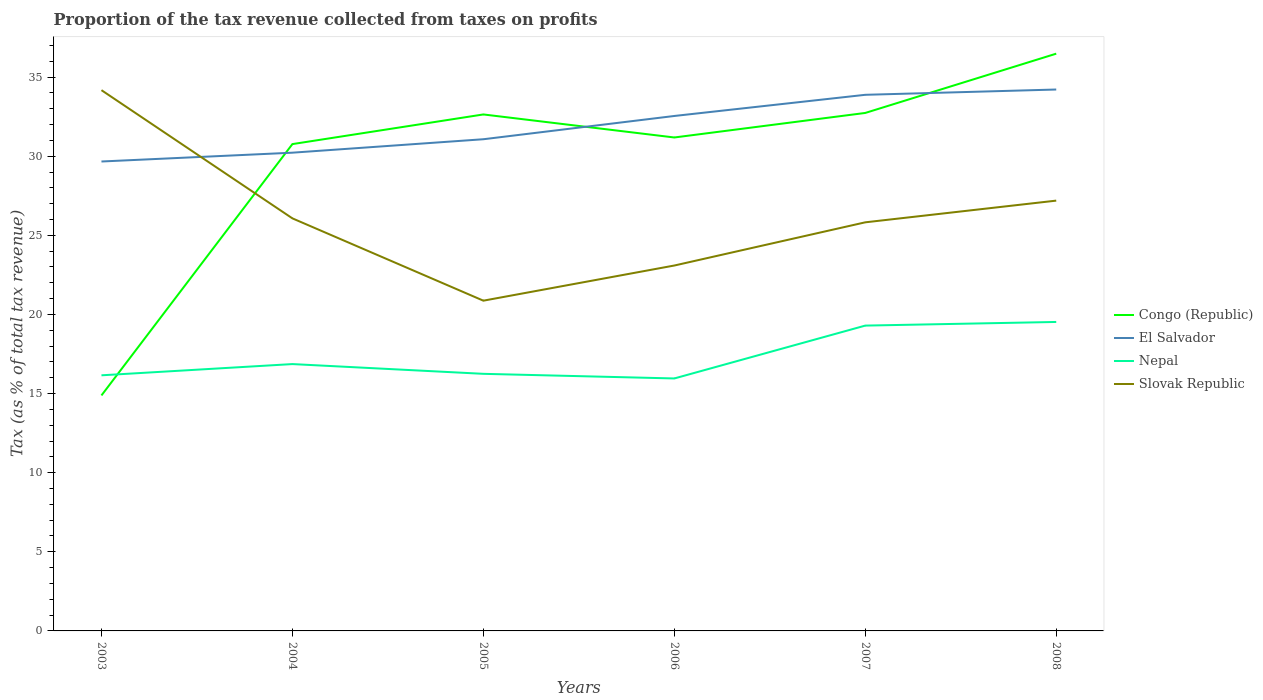How many different coloured lines are there?
Give a very brief answer. 4. Does the line corresponding to El Salvador intersect with the line corresponding to Slovak Republic?
Provide a short and direct response. Yes. Is the number of lines equal to the number of legend labels?
Your answer should be very brief. Yes. Across all years, what is the maximum proportion of the tax revenue collected in El Salvador?
Offer a very short reply. 29.66. In which year was the proportion of the tax revenue collected in Nepal maximum?
Your answer should be compact. 2006. What is the total proportion of the tax revenue collected in Congo (Republic) in the graph?
Keep it short and to the point. -16.3. What is the difference between the highest and the second highest proportion of the tax revenue collected in Slovak Republic?
Offer a very short reply. 13.3. How many lines are there?
Your response must be concise. 4. How many years are there in the graph?
Offer a terse response. 6. Does the graph contain any zero values?
Provide a short and direct response. No. Does the graph contain grids?
Offer a very short reply. No. What is the title of the graph?
Give a very brief answer. Proportion of the tax revenue collected from taxes on profits. What is the label or title of the Y-axis?
Provide a short and direct response. Tax (as % of total tax revenue). What is the Tax (as % of total tax revenue) in Congo (Republic) in 2003?
Make the answer very short. 14.88. What is the Tax (as % of total tax revenue) in El Salvador in 2003?
Your answer should be compact. 29.66. What is the Tax (as % of total tax revenue) of Nepal in 2003?
Your answer should be very brief. 16.15. What is the Tax (as % of total tax revenue) of Slovak Republic in 2003?
Keep it short and to the point. 34.17. What is the Tax (as % of total tax revenue) of Congo (Republic) in 2004?
Keep it short and to the point. 30.77. What is the Tax (as % of total tax revenue) in El Salvador in 2004?
Offer a terse response. 30.22. What is the Tax (as % of total tax revenue) of Nepal in 2004?
Give a very brief answer. 16.86. What is the Tax (as % of total tax revenue) in Slovak Republic in 2004?
Your response must be concise. 26.07. What is the Tax (as % of total tax revenue) in Congo (Republic) in 2005?
Offer a terse response. 32.64. What is the Tax (as % of total tax revenue) of El Salvador in 2005?
Provide a succinct answer. 31.07. What is the Tax (as % of total tax revenue) of Nepal in 2005?
Offer a very short reply. 16.25. What is the Tax (as % of total tax revenue) of Slovak Republic in 2005?
Your response must be concise. 20.87. What is the Tax (as % of total tax revenue) of Congo (Republic) in 2006?
Your answer should be compact. 31.18. What is the Tax (as % of total tax revenue) in El Salvador in 2006?
Ensure brevity in your answer.  32.54. What is the Tax (as % of total tax revenue) in Nepal in 2006?
Your answer should be very brief. 15.95. What is the Tax (as % of total tax revenue) in Slovak Republic in 2006?
Your answer should be very brief. 23.09. What is the Tax (as % of total tax revenue) of Congo (Republic) in 2007?
Offer a very short reply. 32.73. What is the Tax (as % of total tax revenue) in El Salvador in 2007?
Provide a succinct answer. 33.88. What is the Tax (as % of total tax revenue) in Nepal in 2007?
Your answer should be very brief. 19.3. What is the Tax (as % of total tax revenue) of Slovak Republic in 2007?
Provide a succinct answer. 25.82. What is the Tax (as % of total tax revenue) in Congo (Republic) in 2008?
Keep it short and to the point. 36.48. What is the Tax (as % of total tax revenue) in El Salvador in 2008?
Your answer should be compact. 34.21. What is the Tax (as % of total tax revenue) of Nepal in 2008?
Your response must be concise. 19.53. What is the Tax (as % of total tax revenue) of Slovak Republic in 2008?
Offer a very short reply. 27.19. Across all years, what is the maximum Tax (as % of total tax revenue) of Congo (Republic)?
Your answer should be compact. 36.48. Across all years, what is the maximum Tax (as % of total tax revenue) of El Salvador?
Make the answer very short. 34.21. Across all years, what is the maximum Tax (as % of total tax revenue) in Nepal?
Your answer should be compact. 19.53. Across all years, what is the maximum Tax (as % of total tax revenue) in Slovak Republic?
Your answer should be very brief. 34.17. Across all years, what is the minimum Tax (as % of total tax revenue) in Congo (Republic)?
Give a very brief answer. 14.88. Across all years, what is the minimum Tax (as % of total tax revenue) in El Salvador?
Your response must be concise. 29.66. Across all years, what is the minimum Tax (as % of total tax revenue) of Nepal?
Make the answer very short. 15.95. Across all years, what is the minimum Tax (as % of total tax revenue) in Slovak Republic?
Keep it short and to the point. 20.87. What is the total Tax (as % of total tax revenue) of Congo (Republic) in the graph?
Your answer should be compact. 178.68. What is the total Tax (as % of total tax revenue) of El Salvador in the graph?
Your answer should be very brief. 191.6. What is the total Tax (as % of total tax revenue) in Nepal in the graph?
Provide a succinct answer. 104.04. What is the total Tax (as % of total tax revenue) of Slovak Republic in the graph?
Your answer should be very brief. 157.22. What is the difference between the Tax (as % of total tax revenue) in Congo (Republic) in 2003 and that in 2004?
Provide a short and direct response. -15.88. What is the difference between the Tax (as % of total tax revenue) of El Salvador in 2003 and that in 2004?
Keep it short and to the point. -0.56. What is the difference between the Tax (as % of total tax revenue) in Nepal in 2003 and that in 2004?
Make the answer very short. -0.71. What is the difference between the Tax (as % of total tax revenue) in Slovak Republic in 2003 and that in 2004?
Offer a terse response. 8.1. What is the difference between the Tax (as % of total tax revenue) of Congo (Republic) in 2003 and that in 2005?
Keep it short and to the point. -17.76. What is the difference between the Tax (as % of total tax revenue) of El Salvador in 2003 and that in 2005?
Your response must be concise. -1.41. What is the difference between the Tax (as % of total tax revenue) of Nepal in 2003 and that in 2005?
Your answer should be compact. -0.09. What is the difference between the Tax (as % of total tax revenue) in Slovak Republic in 2003 and that in 2005?
Provide a succinct answer. 13.3. What is the difference between the Tax (as % of total tax revenue) in Congo (Republic) in 2003 and that in 2006?
Offer a very short reply. -16.3. What is the difference between the Tax (as % of total tax revenue) in El Salvador in 2003 and that in 2006?
Provide a succinct answer. -2.88. What is the difference between the Tax (as % of total tax revenue) of Nepal in 2003 and that in 2006?
Your answer should be compact. 0.2. What is the difference between the Tax (as % of total tax revenue) in Slovak Republic in 2003 and that in 2006?
Provide a short and direct response. 11.08. What is the difference between the Tax (as % of total tax revenue) in Congo (Republic) in 2003 and that in 2007?
Give a very brief answer. -17.85. What is the difference between the Tax (as % of total tax revenue) of El Salvador in 2003 and that in 2007?
Offer a terse response. -4.22. What is the difference between the Tax (as % of total tax revenue) of Nepal in 2003 and that in 2007?
Make the answer very short. -3.14. What is the difference between the Tax (as % of total tax revenue) of Slovak Republic in 2003 and that in 2007?
Your response must be concise. 8.35. What is the difference between the Tax (as % of total tax revenue) of Congo (Republic) in 2003 and that in 2008?
Give a very brief answer. -21.6. What is the difference between the Tax (as % of total tax revenue) in El Salvador in 2003 and that in 2008?
Ensure brevity in your answer.  -4.55. What is the difference between the Tax (as % of total tax revenue) of Nepal in 2003 and that in 2008?
Give a very brief answer. -3.37. What is the difference between the Tax (as % of total tax revenue) of Slovak Republic in 2003 and that in 2008?
Your response must be concise. 6.98. What is the difference between the Tax (as % of total tax revenue) in Congo (Republic) in 2004 and that in 2005?
Keep it short and to the point. -1.87. What is the difference between the Tax (as % of total tax revenue) in El Salvador in 2004 and that in 2005?
Your answer should be compact. -0.85. What is the difference between the Tax (as % of total tax revenue) of Nepal in 2004 and that in 2005?
Offer a very short reply. 0.62. What is the difference between the Tax (as % of total tax revenue) of Slovak Republic in 2004 and that in 2005?
Your answer should be compact. 5.2. What is the difference between the Tax (as % of total tax revenue) of Congo (Republic) in 2004 and that in 2006?
Ensure brevity in your answer.  -0.42. What is the difference between the Tax (as % of total tax revenue) of El Salvador in 2004 and that in 2006?
Your answer should be very brief. -2.32. What is the difference between the Tax (as % of total tax revenue) in Nepal in 2004 and that in 2006?
Your answer should be compact. 0.91. What is the difference between the Tax (as % of total tax revenue) in Slovak Republic in 2004 and that in 2006?
Your response must be concise. 2.98. What is the difference between the Tax (as % of total tax revenue) in Congo (Republic) in 2004 and that in 2007?
Your answer should be compact. -1.97. What is the difference between the Tax (as % of total tax revenue) of El Salvador in 2004 and that in 2007?
Provide a succinct answer. -3.66. What is the difference between the Tax (as % of total tax revenue) in Nepal in 2004 and that in 2007?
Your answer should be compact. -2.43. What is the difference between the Tax (as % of total tax revenue) of Slovak Republic in 2004 and that in 2007?
Keep it short and to the point. 0.25. What is the difference between the Tax (as % of total tax revenue) in Congo (Republic) in 2004 and that in 2008?
Your answer should be very brief. -5.71. What is the difference between the Tax (as % of total tax revenue) in El Salvador in 2004 and that in 2008?
Your answer should be very brief. -3.99. What is the difference between the Tax (as % of total tax revenue) of Nepal in 2004 and that in 2008?
Offer a very short reply. -2.66. What is the difference between the Tax (as % of total tax revenue) of Slovak Republic in 2004 and that in 2008?
Your answer should be compact. -1.12. What is the difference between the Tax (as % of total tax revenue) in Congo (Republic) in 2005 and that in 2006?
Your answer should be very brief. 1.46. What is the difference between the Tax (as % of total tax revenue) in El Salvador in 2005 and that in 2006?
Keep it short and to the point. -1.47. What is the difference between the Tax (as % of total tax revenue) of Nepal in 2005 and that in 2006?
Make the answer very short. 0.29. What is the difference between the Tax (as % of total tax revenue) in Slovak Republic in 2005 and that in 2006?
Give a very brief answer. -2.22. What is the difference between the Tax (as % of total tax revenue) of Congo (Republic) in 2005 and that in 2007?
Offer a terse response. -0.09. What is the difference between the Tax (as % of total tax revenue) of El Salvador in 2005 and that in 2007?
Your response must be concise. -2.81. What is the difference between the Tax (as % of total tax revenue) in Nepal in 2005 and that in 2007?
Your response must be concise. -3.05. What is the difference between the Tax (as % of total tax revenue) in Slovak Republic in 2005 and that in 2007?
Give a very brief answer. -4.95. What is the difference between the Tax (as % of total tax revenue) of Congo (Republic) in 2005 and that in 2008?
Offer a very short reply. -3.84. What is the difference between the Tax (as % of total tax revenue) of El Salvador in 2005 and that in 2008?
Your response must be concise. -3.14. What is the difference between the Tax (as % of total tax revenue) in Nepal in 2005 and that in 2008?
Keep it short and to the point. -3.28. What is the difference between the Tax (as % of total tax revenue) in Slovak Republic in 2005 and that in 2008?
Your response must be concise. -6.32. What is the difference between the Tax (as % of total tax revenue) in Congo (Republic) in 2006 and that in 2007?
Provide a short and direct response. -1.55. What is the difference between the Tax (as % of total tax revenue) of El Salvador in 2006 and that in 2007?
Give a very brief answer. -1.34. What is the difference between the Tax (as % of total tax revenue) of Nepal in 2006 and that in 2007?
Make the answer very short. -3.34. What is the difference between the Tax (as % of total tax revenue) of Slovak Republic in 2006 and that in 2007?
Keep it short and to the point. -2.73. What is the difference between the Tax (as % of total tax revenue) in Congo (Republic) in 2006 and that in 2008?
Offer a very short reply. -5.3. What is the difference between the Tax (as % of total tax revenue) of El Salvador in 2006 and that in 2008?
Give a very brief answer. -1.67. What is the difference between the Tax (as % of total tax revenue) of Nepal in 2006 and that in 2008?
Make the answer very short. -3.57. What is the difference between the Tax (as % of total tax revenue) of Slovak Republic in 2006 and that in 2008?
Provide a short and direct response. -4.1. What is the difference between the Tax (as % of total tax revenue) in Congo (Republic) in 2007 and that in 2008?
Your answer should be compact. -3.75. What is the difference between the Tax (as % of total tax revenue) in El Salvador in 2007 and that in 2008?
Give a very brief answer. -0.33. What is the difference between the Tax (as % of total tax revenue) in Nepal in 2007 and that in 2008?
Keep it short and to the point. -0.23. What is the difference between the Tax (as % of total tax revenue) in Slovak Republic in 2007 and that in 2008?
Your answer should be very brief. -1.37. What is the difference between the Tax (as % of total tax revenue) in Congo (Republic) in 2003 and the Tax (as % of total tax revenue) in El Salvador in 2004?
Your response must be concise. -15.34. What is the difference between the Tax (as % of total tax revenue) of Congo (Republic) in 2003 and the Tax (as % of total tax revenue) of Nepal in 2004?
Provide a short and direct response. -1.98. What is the difference between the Tax (as % of total tax revenue) of Congo (Republic) in 2003 and the Tax (as % of total tax revenue) of Slovak Republic in 2004?
Provide a succinct answer. -11.19. What is the difference between the Tax (as % of total tax revenue) in El Salvador in 2003 and the Tax (as % of total tax revenue) in Nepal in 2004?
Provide a succinct answer. 12.8. What is the difference between the Tax (as % of total tax revenue) of El Salvador in 2003 and the Tax (as % of total tax revenue) of Slovak Republic in 2004?
Offer a very short reply. 3.59. What is the difference between the Tax (as % of total tax revenue) of Nepal in 2003 and the Tax (as % of total tax revenue) of Slovak Republic in 2004?
Your answer should be compact. -9.92. What is the difference between the Tax (as % of total tax revenue) of Congo (Republic) in 2003 and the Tax (as % of total tax revenue) of El Salvador in 2005?
Provide a short and direct response. -16.19. What is the difference between the Tax (as % of total tax revenue) in Congo (Republic) in 2003 and the Tax (as % of total tax revenue) in Nepal in 2005?
Make the answer very short. -1.37. What is the difference between the Tax (as % of total tax revenue) in Congo (Republic) in 2003 and the Tax (as % of total tax revenue) in Slovak Republic in 2005?
Your answer should be very brief. -5.99. What is the difference between the Tax (as % of total tax revenue) in El Salvador in 2003 and the Tax (as % of total tax revenue) in Nepal in 2005?
Give a very brief answer. 13.42. What is the difference between the Tax (as % of total tax revenue) of El Salvador in 2003 and the Tax (as % of total tax revenue) of Slovak Republic in 2005?
Your response must be concise. 8.79. What is the difference between the Tax (as % of total tax revenue) in Nepal in 2003 and the Tax (as % of total tax revenue) in Slovak Republic in 2005?
Your answer should be compact. -4.72. What is the difference between the Tax (as % of total tax revenue) of Congo (Republic) in 2003 and the Tax (as % of total tax revenue) of El Salvador in 2006?
Your answer should be very brief. -17.66. What is the difference between the Tax (as % of total tax revenue) in Congo (Republic) in 2003 and the Tax (as % of total tax revenue) in Nepal in 2006?
Give a very brief answer. -1.07. What is the difference between the Tax (as % of total tax revenue) in Congo (Republic) in 2003 and the Tax (as % of total tax revenue) in Slovak Republic in 2006?
Make the answer very short. -8.21. What is the difference between the Tax (as % of total tax revenue) of El Salvador in 2003 and the Tax (as % of total tax revenue) of Nepal in 2006?
Ensure brevity in your answer.  13.71. What is the difference between the Tax (as % of total tax revenue) in El Salvador in 2003 and the Tax (as % of total tax revenue) in Slovak Republic in 2006?
Keep it short and to the point. 6.57. What is the difference between the Tax (as % of total tax revenue) in Nepal in 2003 and the Tax (as % of total tax revenue) in Slovak Republic in 2006?
Your response must be concise. -6.94. What is the difference between the Tax (as % of total tax revenue) of Congo (Republic) in 2003 and the Tax (as % of total tax revenue) of El Salvador in 2007?
Ensure brevity in your answer.  -19. What is the difference between the Tax (as % of total tax revenue) of Congo (Republic) in 2003 and the Tax (as % of total tax revenue) of Nepal in 2007?
Give a very brief answer. -4.41. What is the difference between the Tax (as % of total tax revenue) in Congo (Republic) in 2003 and the Tax (as % of total tax revenue) in Slovak Republic in 2007?
Offer a terse response. -10.94. What is the difference between the Tax (as % of total tax revenue) of El Salvador in 2003 and the Tax (as % of total tax revenue) of Nepal in 2007?
Your response must be concise. 10.37. What is the difference between the Tax (as % of total tax revenue) in El Salvador in 2003 and the Tax (as % of total tax revenue) in Slovak Republic in 2007?
Offer a terse response. 3.84. What is the difference between the Tax (as % of total tax revenue) in Nepal in 2003 and the Tax (as % of total tax revenue) in Slovak Republic in 2007?
Your response must be concise. -9.67. What is the difference between the Tax (as % of total tax revenue) in Congo (Republic) in 2003 and the Tax (as % of total tax revenue) in El Salvador in 2008?
Your answer should be compact. -19.33. What is the difference between the Tax (as % of total tax revenue) of Congo (Republic) in 2003 and the Tax (as % of total tax revenue) of Nepal in 2008?
Your response must be concise. -4.64. What is the difference between the Tax (as % of total tax revenue) in Congo (Republic) in 2003 and the Tax (as % of total tax revenue) in Slovak Republic in 2008?
Ensure brevity in your answer.  -12.31. What is the difference between the Tax (as % of total tax revenue) of El Salvador in 2003 and the Tax (as % of total tax revenue) of Nepal in 2008?
Your response must be concise. 10.14. What is the difference between the Tax (as % of total tax revenue) of El Salvador in 2003 and the Tax (as % of total tax revenue) of Slovak Republic in 2008?
Offer a terse response. 2.47. What is the difference between the Tax (as % of total tax revenue) of Nepal in 2003 and the Tax (as % of total tax revenue) of Slovak Republic in 2008?
Your answer should be compact. -11.04. What is the difference between the Tax (as % of total tax revenue) in Congo (Republic) in 2004 and the Tax (as % of total tax revenue) in El Salvador in 2005?
Provide a succinct answer. -0.31. What is the difference between the Tax (as % of total tax revenue) of Congo (Republic) in 2004 and the Tax (as % of total tax revenue) of Nepal in 2005?
Give a very brief answer. 14.52. What is the difference between the Tax (as % of total tax revenue) of Congo (Republic) in 2004 and the Tax (as % of total tax revenue) of Slovak Republic in 2005?
Your answer should be very brief. 9.9. What is the difference between the Tax (as % of total tax revenue) of El Salvador in 2004 and the Tax (as % of total tax revenue) of Nepal in 2005?
Provide a short and direct response. 13.98. What is the difference between the Tax (as % of total tax revenue) of El Salvador in 2004 and the Tax (as % of total tax revenue) of Slovak Republic in 2005?
Offer a terse response. 9.35. What is the difference between the Tax (as % of total tax revenue) in Nepal in 2004 and the Tax (as % of total tax revenue) in Slovak Republic in 2005?
Make the answer very short. -4.01. What is the difference between the Tax (as % of total tax revenue) of Congo (Republic) in 2004 and the Tax (as % of total tax revenue) of El Salvador in 2006?
Provide a short and direct response. -1.78. What is the difference between the Tax (as % of total tax revenue) in Congo (Republic) in 2004 and the Tax (as % of total tax revenue) in Nepal in 2006?
Provide a short and direct response. 14.81. What is the difference between the Tax (as % of total tax revenue) in Congo (Republic) in 2004 and the Tax (as % of total tax revenue) in Slovak Republic in 2006?
Keep it short and to the point. 7.67. What is the difference between the Tax (as % of total tax revenue) in El Salvador in 2004 and the Tax (as % of total tax revenue) in Nepal in 2006?
Make the answer very short. 14.27. What is the difference between the Tax (as % of total tax revenue) of El Salvador in 2004 and the Tax (as % of total tax revenue) of Slovak Republic in 2006?
Ensure brevity in your answer.  7.13. What is the difference between the Tax (as % of total tax revenue) of Nepal in 2004 and the Tax (as % of total tax revenue) of Slovak Republic in 2006?
Give a very brief answer. -6.23. What is the difference between the Tax (as % of total tax revenue) of Congo (Republic) in 2004 and the Tax (as % of total tax revenue) of El Salvador in 2007?
Your answer should be very brief. -3.11. What is the difference between the Tax (as % of total tax revenue) of Congo (Republic) in 2004 and the Tax (as % of total tax revenue) of Nepal in 2007?
Offer a very short reply. 11.47. What is the difference between the Tax (as % of total tax revenue) in Congo (Republic) in 2004 and the Tax (as % of total tax revenue) in Slovak Republic in 2007?
Ensure brevity in your answer.  4.94. What is the difference between the Tax (as % of total tax revenue) in El Salvador in 2004 and the Tax (as % of total tax revenue) in Nepal in 2007?
Ensure brevity in your answer.  10.93. What is the difference between the Tax (as % of total tax revenue) in El Salvador in 2004 and the Tax (as % of total tax revenue) in Slovak Republic in 2007?
Offer a terse response. 4.4. What is the difference between the Tax (as % of total tax revenue) of Nepal in 2004 and the Tax (as % of total tax revenue) of Slovak Republic in 2007?
Offer a very short reply. -8.96. What is the difference between the Tax (as % of total tax revenue) in Congo (Republic) in 2004 and the Tax (as % of total tax revenue) in El Salvador in 2008?
Your answer should be very brief. -3.45. What is the difference between the Tax (as % of total tax revenue) in Congo (Republic) in 2004 and the Tax (as % of total tax revenue) in Nepal in 2008?
Offer a terse response. 11.24. What is the difference between the Tax (as % of total tax revenue) of Congo (Republic) in 2004 and the Tax (as % of total tax revenue) of Slovak Republic in 2008?
Provide a succinct answer. 3.57. What is the difference between the Tax (as % of total tax revenue) in El Salvador in 2004 and the Tax (as % of total tax revenue) in Nepal in 2008?
Provide a succinct answer. 10.7. What is the difference between the Tax (as % of total tax revenue) in El Salvador in 2004 and the Tax (as % of total tax revenue) in Slovak Republic in 2008?
Offer a terse response. 3.03. What is the difference between the Tax (as % of total tax revenue) of Nepal in 2004 and the Tax (as % of total tax revenue) of Slovak Republic in 2008?
Provide a succinct answer. -10.33. What is the difference between the Tax (as % of total tax revenue) in Congo (Republic) in 2005 and the Tax (as % of total tax revenue) in El Salvador in 2006?
Offer a terse response. 0.1. What is the difference between the Tax (as % of total tax revenue) of Congo (Republic) in 2005 and the Tax (as % of total tax revenue) of Nepal in 2006?
Provide a short and direct response. 16.68. What is the difference between the Tax (as % of total tax revenue) of Congo (Republic) in 2005 and the Tax (as % of total tax revenue) of Slovak Republic in 2006?
Make the answer very short. 9.55. What is the difference between the Tax (as % of total tax revenue) in El Salvador in 2005 and the Tax (as % of total tax revenue) in Nepal in 2006?
Ensure brevity in your answer.  15.12. What is the difference between the Tax (as % of total tax revenue) of El Salvador in 2005 and the Tax (as % of total tax revenue) of Slovak Republic in 2006?
Ensure brevity in your answer.  7.98. What is the difference between the Tax (as % of total tax revenue) in Nepal in 2005 and the Tax (as % of total tax revenue) in Slovak Republic in 2006?
Your answer should be very brief. -6.84. What is the difference between the Tax (as % of total tax revenue) of Congo (Republic) in 2005 and the Tax (as % of total tax revenue) of El Salvador in 2007?
Ensure brevity in your answer.  -1.24. What is the difference between the Tax (as % of total tax revenue) in Congo (Republic) in 2005 and the Tax (as % of total tax revenue) in Nepal in 2007?
Offer a terse response. 13.34. What is the difference between the Tax (as % of total tax revenue) in Congo (Republic) in 2005 and the Tax (as % of total tax revenue) in Slovak Republic in 2007?
Provide a succinct answer. 6.82. What is the difference between the Tax (as % of total tax revenue) in El Salvador in 2005 and the Tax (as % of total tax revenue) in Nepal in 2007?
Keep it short and to the point. 11.78. What is the difference between the Tax (as % of total tax revenue) in El Salvador in 2005 and the Tax (as % of total tax revenue) in Slovak Republic in 2007?
Make the answer very short. 5.25. What is the difference between the Tax (as % of total tax revenue) in Nepal in 2005 and the Tax (as % of total tax revenue) in Slovak Republic in 2007?
Offer a terse response. -9.57. What is the difference between the Tax (as % of total tax revenue) of Congo (Republic) in 2005 and the Tax (as % of total tax revenue) of El Salvador in 2008?
Keep it short and to the point. -1.58. What is the difference between the Tax (as % of total tax revenue) in Congo (Republic) in 2005 and the Tax (as % of total tax revenue) in Nepal in 2008?
Provide a succinct answer. 13.11. What is the difference between the Tax (as % of total tax revenue) of Congo (Republic) in 2005 and the Tax (as % of total tax revenue) of Slovak Republic in 2008?
Give a very brief answer. 5.45. What is the difference between the Tax (as % of total tax revenue) in El Salvador in 2005 and the Tax (as % of total tax revenue) in Nepal in 2008?
Provide a short and direct response. 11.55. What is the difference between the Tax (as % of total tax revenue) in El Salvador in 2005 and the Tax (as % of total tax revenue) in Slovak Republic in 2008?
Your answer should be compact. 3.88. What is the difference between the Tax (as % of total tax revenue) in Nepal in 2005 and the Tax (as % of total tax revenue) in Slovak Republic in 2008?
Provide a short and direct response. -10.95. What is the difference between the Tax (as % of total tax revenue) of Congo (Republic) in 2006 and the Tax (as % of total tax revenue) of El Salvador in 2007?
Your answer should be very brief. -2.7. What is the difference between the Tax (as % of total tax revenue) of Congo (Republic) in 2006 and the Tax (as % of total tax revenue) of Nepal in 2007?
Offer a very short reply. 11.89. What is the difference between the Tax (as % of total tax revenue) of Congo (Republic) in 2006 and the Tax (as % of total tax revenue) of Slovak Republic in 2007?
Offer a terse response. 5.36. What is the difference between the Tax (as % of total tax revenue) of El Salvador in 2006 and the Tax (as % of total tax revenue) of Nepal in 2007?
Offer a terse response. 13.25. What is the difference between the Tax (as % of total tax revenue) of El Salvador in 2006 and the Tax (as % of total tax revenue) of Slovak Republic in 2007?
Provide a succinct answer. 6.72. What is the difference between the Tax (as % of total tax revenue) in Nepal in 2006 and the Tax (as % of total tax revenue) in Slovak Republic in 2007?
Give a very brief answer. -9.87. What is the difference between the Tax (as % of total tax revenue) of Congo (Republic) in 2006 and the Tax (as % of total tax revenue) of El Salvador in 2008?
Offer a terse response. -3.03. What is the difference between the Tax (as % of total tax revenue) in Congo (Republic) in 2006 and the Tax (as % of total tax revenue) in Nepal in 2008?
Give a very brief answer. 11.66. What is the difference between the Tax (as % of total tax revenue) in Congo (Republic) in 2006 and the Tax (as % of total tax revenue) in Slovak Republic in 2008?
Offer a terse response. 3.99. What is the difference between the Tax (as % of total tax revenue) in El Salvador in 2006 and the Tax (as % of total tax revenue) in Nepal in 2008?
Provide a short and direct response. 13.02. What is the difference between the Tax (as % of total tax revenue) in El Salvador in 2006 and the Tax (as % of total tax revenue) in Slovak Republic in 2008?
Provide a succinct answer. 5.35. What is the difference between the Tax (as % of total tax revenue) in Nepal in 2006 and the Tax (as % of total tax revenue) in Slovak Republic in 2008?
Provide a succinct answer. -11.24. What is the difference between the Tax (as % of total tax revenue) in Congo (Republic) in 2007 and the Tax (as % of total tax revenue) in El Salvador in 2008?
Provide a short and direct response. -1.48. What is the difference between the Tax (as % of total tax revenue) in Congo (Republic) in 2007 and the Tax (as % of total tax revenue) in Nepal in 2008?
Provide a short and direct response. 13.21. What is the difference between the Tax (as % of total tax revenue) of Congo (Republic) in 2007 and the Tax (as % of total tax revenue) of Slovak Republic in 2008?
Offer a very short reply. 5.54. What is the difference between the Tax (as % of total tax revenue) of El Salvador in 2007 and the Tax (as % of total tax revenue) of Nepal in 2008?
Your answer should be very brief. 14.35. What is the difference between the Tax (as % of total tax revenue) of El Salvador in 2007 and the Tax (as % of total tax revenue) of Slovak Republic in 2008?
Give a very brief answer. 6.69. What is the difference between the Tax (as % of total tax revenue) of Nepal in 2007 and the Tax (as % of total tax revenue) of Slovak Republic in 2008?
Give a very brief answer. -7.9. What is the average Tax (as % of total tax revenue) in Congo (Republic) per year?
Keep it short and to the point. 29.78. What is the average Tax (as % of total tax revenue) of El Salvador per year?
Ensure brevity in your answer.  31.93. What is the average Tax (as % of total tax revenue) in Nepal per year?
Your answer should be compact. 17.34. What is the average Tax (as % of total tax revenue) of Slovak Republic per year?
Keep it short and to the point. 26.2. In the year 2003, what is the difference between the Tax (as % of total tax revenue) in Congo (Republic) and Tax (as % of total tax revenue) in El Salvador?
Keep it short and to the point. -14.78. In the year 2003, what is the difference between the Tax (as % of total tax revenue) in Congo (Republic) and Tax (as % of total tax revenue) in Nepal?
Keep it short and to the point. -1.27. In the year 2003, what is the difference between the Tax (as % of total tax revenue) in Congo (Republic) and Tax (as % of total tax revenue) in Slovak Republic?
Provide a short and direct response. -19.29. In the year 2003, what is the difference between the Tax (as % of total tax revenue) of El Salvador and Tax (as % of total tax revenue) of Nepal?
Make the answer very short. 13.51. In the year 2003, what is the difference between the Tax (as % of total tax revenue) of El Salvador and Tax (as % of total tax revenue) of Slovak Republic?
Keep it short and to the point. -4.51. In the year 2003, what is the difference between the Tax (as % of total tax revenue) of Nepal and Tax (as % of total tax revenue) of Slovak Republic?
Offer a very short reply. -18.02. In the year 2004, what is the difference between the Tax (as % of total tax revenue) in Congo (Republic) and Tax (as % of total tax revenue) in El Salvador?
Provide a short and direct response. 0.54. In the year 2004, what is the difference between the Tax (as % of total tax revenue) of Congo (Republic) and Tax (as % of total tax revenue) of Nepal?
Offer a very short reply. 13.9. In the year 2004, what is the difference between the Tax (as % of total tax revenue) in Congo (Republic) and Tax (as % of total tax revenue) in Slovak Republic?
Your answer should be compact. 4.69. In the year 2004, what is the difference between the Tax (as % of total tax revenue) of El Salvador and Tax (as % of total tax revenue) of Nepal?
Your response must be concise. 13.36. In the year 2004, what is the difference between the Tax (as % of total tax revenue) in El Salvador and Tax (as % of total tax revenue) in Slovak Republic?
Offer a very short reply. 4.15. In the year 2004, what is the difference between the Tax (as % of total tax revenue) in Nepal and Tax (as % of total tax revenue) in Slovak Republic?
Your answer should be compact. -9.21. In the year 2005, what is the difference between the Tax (as % of total tax revenue) of Congo (Republic) and Tax (as % of total tax revenue) of El Salvador?
Your answer should be compact. 1.57. In the year 2005, what is the difference between the Tax (as % of total tax revenue) in Congo (Republic) and Tax (as % of total tax revenue) in Nepal?
Your answer should be very brief. 16.39. In the year 2005, what is the difference between the Tax (as % of total tax revenue) in Congo (Republic) and Tax (as % of total tax revenue) in Slovak Republic?
Offer a very short reply. 11.77. In the year 2005, what is the difference between the Tax (as % of total tax revenue) of El Salvador and Tax (as % of total tax revenue) of Nepal?
Offer a terse response. 14.82. In the year 2005, what is the difference between the Tax (as % of total tax revenue) of El Salvador and Tax (as % of total tax revenue) of Slovak Republic?
Offer a very short reply. 10.2. In the year 2005, what is the difference between the Tax (as % of total tax revenue) in Nepal and Tax (as % of total tax revenue) in Slovak Republic?
Provide a short and direct response. -4.62. In the year 2006, what is the difference between the Tax (as % of total tax revenue) of Congo (Republic) and Tax (as % of total tax revenue) of El Salvador?
Give a very brief answer. -1.36. In the year 2006, what is the difference between the Tax (as % of total tax revenue) in Congo (Republic) and Tax (as % of total tax revenue) in Nepal?
Ensure brevity in your answer.  15.23. In the year 2006, what is the difference between the Tax (as % of total tax revenue) in Congo (Republic) and Tax (as % of total tax revenue) in Slovak Republic?
Keep it short and to the point. 8.09. In the year 2006, what is the difference between the Tax (as % of total tax revenue) in El Salvador and Tax (as % of total tax revenue) in Nepal?
Your answer should be compact. 16.59. In the year 2006, what is the difference between the Tax (as % of total tax revenue) of El Salvador and Tax (as % of total tax revenue) of Slovak Republic?
Offer a terse response. 9.45. In the year 2006, what is the difference between the Tax (as % of total tax revenue) in Nepal and Tax (as % of total tax revenue) in Slovak Republic?
Your answer should be compact. -7.14. In the year 2007, what is the difference between the Tax (as % of total tax revenue) in Congo (Republic) and Tax (as % of total tax revenue) in El Salvador?
Your response must be concise. -1.15. In the year 2007, what is the difference between the Tax (as % of total tax revenue) in Congo (Republic) and Tax (as % of total tax revenue) in Nepal?
Offer a terse response. 13.44. In the year 2007, what is the difference between the Tax (as % of total tax revenue) of Congo (Republic) and Tax (as % of total tax revenue) of Slovak Republic?
Offer a very short reply. 6.91. In the year 2007, what is the difference between the Tax (as % of total tax revenue) of El Salvador and Tax (as % of total tax revenue) of Nepal?
Your answer should be very brief. 14.58. In the year 2007, what is the difference between the Tax (as % of total tax revenue) of El Salvador and Tax (as % of total tax revenue) of Slovak Republic?
Provide a succinct answer. 8.06. In the year 2007, what is the difference between the Tax (as % of total tax revenue) of Nepal and Tax (as % of total tax revenue) of Slovak Republic?
Your answer should be very brief. -6.53. In the year 2008, what is the difference between the Tax (as % of total tax revenue) in Congo (Republic) and Tax (as % of total tax revenue) in El Salvador?
Make the answer very short. 2.27. In the year 2008, what is the difference between the Tax (as % of total tax revenue) in Congo (Republic) and Tax (as % of total tax revenue) in Nepal?
Provide a succinct answer. 16.95. In the year 2008, what is the difference between the Tax (as % of total tax revenue) of Congo (Republic) and Tax (as % of total tax revenue) of Slovak Republic?
Your answer should be compact. 9.29. In the year 2008, what is the difference between the Tax (as % of total tax revenue) of El Salvador and Tax (as % of total tax revenue) of Nepal?
Provide a succinct answer. 14.69. In the year 2008, what is the difference between the Tax (as % of total tax revenue) in El Salvador and Tax (as % of total tax revenue) in Slovak Republic?
Your answer should be compact. 7.02. In the year 2008, what is the difference between the Tax (as % of total tax revenue) of Nepal and Tax (as % of total tax revenue) of Slovak Republic?
Offer a terse response. -7.67. What is the ratio of the Tax (as % of total tax revenue) in Congo (Republic) in 2003 to that in 2004?
Offer a terse response. 0.48. What is the ratio of the Tax (as % of total tax revenue) of El Salvador in 2003 to that in 2004?
Provide a short and direct response. 0.98. What is the ratio of the Tax (as % of total tax revenue) in Nepal in 2003 to that in 2004?
Provide a succinct answer. 0.96. What is the ratio of the Tax (as % of total tax revenue) in Slovak Republic in 2003 to that in 2004?
Provide a short and direct response. 1.31. What is the ratio of the Tax (as % of total tax revenue) in Congo (Republic) in 2003 to that in 2005?
Provide a short and direct response. 0.46. What is the ratio of the Tax (as % of total tax revenue) of El Salvador in 2003 to that in 2005?
Your response must be concise. 0.95. What is the ratio of the Tax (as % of total tax revenue) in Nepal in 2003 to that in 2005?
Make the answer very short. 0.99. What is the ratio of the Tax (as % of total tax revenue) in Slovak Republic in 2003 to that in 2005?
Your answer should be very brief. 1.64. What is the ratio of the Tax (as % of total tax revenue) of Congo (Republic) in 2003 to that in 2006?
Give a very brief answer. 0.48. What is the ratio of the Tax (as % of total tax revenue) of El Salvador in 2003 to that in 2006?
Ensure brevity in your answer.  0.91. What is the ratio of the Tax (as % of total tax revenue) of Nepal in 2003 to that in 2006?
Make the answer very short. 1.01. What is the ratio of the Tax (as % of total tax revenue) of Slovak Republic in 2003 to that in 2006?
Give a very brief answer. 1.48. What is the ratio of the Tax (as % of total tax revenue) in Congo (Republic) in 2003 to that in 2007?
Give a very brief answer. 0.45. What is the ratio of the Tax (as % of total tax revenue) of El Salvador in 2003 to that in 2007?
Offer a terse response. 0.88. What is the ratio of the Tax (as % of total tax revenue) in Nepal in 2003 to that in 2007?
Provide a short and direct response. 0.84. What is the ratio of the Tax (as % of total tax revenue) of Slovak Republic in 2003 to that in 2007?
Your answer should be compact. 1.32. What is the ratio of the Tax (as % of total tax revenue) of Congo (Republic) in 2003 to that in 2008?
Ensure brevity in your answer.  0.41. What is the ratio of the Tax (as % of total tax revenue) in El Salvador in 2003 to that in 2008?
Give a very brief answer. 0.87. What is the ratio of the Tax (as % of total tax revenue) of Nepal in 2003 to that in 2008?
Your response must be concise. 0.83. What is the ratio of the Tax (as % of total tax revenue) of Slovak Republic in 2003 to that in 2008?
Your answer should be compact. 1.26. What is the ratio of the Tax (as % of total tax revenue) in Congo (Republic) in 2004 to that in 2005?
Keep it short and to the point. 0.94. What is the ratio of the Tax (as % of total tax revenue) of El Salvador in 2004 to that in 2005?
Give a very brief answer. 0.97. What is the ratio of the Tax (as % of total tax revenue) of Nepal in 2004 to that in 2005?
Your answer should be compact. 1.04. What is the ratio of the Tax (as % of total tax revenue) in Slovak Republic in 2004 to that in 2005?
Provide a short and direct response. 1.25. What is the ratio of the Tax (as % of total tax revenue) in Congo (Republic) in 2004 to that in 2006?
Offer a terse response. 0.99. What is the ratio of the Tax (as % of total tax revenue) in El Salvador in 2004 to that in 2006?
Give a very brief answer. 0.93. What is the ratio of the Tax (as % of total tax revenue) of Nepal in 2004 to that in 2006?
Give a very brief answer. 1.06. What is the ratio of the Tax (as % of total tax revenue) in Slovak Republic in 2004 to that in 2006?
Your response must be concise. 1.13. What is the ratio of the Tax (as % of total tax revenue) of Congo (Republic) in 2004 to that in 2007?
Ensure brevity in your answer.  0.94. What is the ratio of the Tax (as % of total tax revenue) in El Salvador in 2004 to that in 2007?
Make the answer very short. 0.89. What is the ratio of the Tax (as % of total tax revenue) in Nepal in 2004 to that in 2007?
Give a very brief answer. 0.87. What is the ratio of the Tax (as % of total tax revenue) in Slovak Republic in 2004 to that in 2007?
Keep it short and to the point. 1.01. What is the ratio of the Tax (as % of total tax revenue) in Congo (Republic) in 2004 to that in 2008?
Offer a very short reply. 0.84. What is the ratio of the Tax (as % of total tax revenue) in El Salvador in 2004 to that in 2008?
Provide a short and direct response. 0.88. What is the ratio of the Tax (as % of total tax revenue) in Nepal in 2004 to that in 2008?
Your answer should be compact. 0.86. What is the ratio of the Tax (as % of total tax revenue) of Slovak Republic in 2004 to that in 2008?
Provide a short and direct response. 0.96. What is the ratio of the Tax (as % of total tax revenue) of Congo (Republic) in 2005 to that in 2006?
Your answer should be very brief. 1.05. What is the ratio of the Tax (as % of total tax revenue) of El Salvador in 2005 to that in 2006?
Give a very brief answer. 0.95. What is the ratio of the Tax (as % of total tax revenue) of Nepal in 2005 to that in 2006?
Give a very brief answer. 1.02. What is the ratio of the Tax (as % of total tax revenue) in Slovak Republic in 2005 to that in 2006?
Your response must be concise. 0.9. What is the ratio of the Tax (as % of total tax revenue) in El Salvador in 2005 to that in 2007?
Your answer should be compact. 0.92. What is the ratio of the Tax (as % of total tax revenue) of Nepal in 2005 to that in 2007?
Give a very brief answer. 0.84. What is the ratio of the Tax (as % of total tax revenue) of Slovak Republic in 2005 to that in 2007?
Keep it short and to the point. 0.81. What is the ratio of the Tax (as % of total tax revenue) in Congo (Republic) in 2005 to that in 2008?
Provide a short and direct response. 0.89. What is the ratio of the Tax (as % of total tax revenue) in El Salvador in 2005 to that in 2008?
Offer a terse response. 0.91. What is the ratio of the Tax (as % of total tax revenue) of Nepal in 2005 to that in 2008?
Your response must be concise. 0.83. What is the ratio of the Tax (as % of total tax revenue) in Slovak Republic in 2005 to that in 2008?
Keep it short and to the point. 0.77. What is the ratio of the Tax (as % of total tax revenue) in Congo (Republic) in 2006 to that in 2007?
Your response must be concise. 0.95. What is the ratio of the Tax (as % of total tax revenue) in El Salvador in 2006 to that in 2007?
Your response must be concise. 0.96. What is the ratio of the Tax (as % of total tax revenue) in Nepal in 2006 to that in 2007?
Your answer should be compact. 0.83. What is the ratio of the Tax (as % of total tax revenue) of Slovak Republic in 2006 to that in 2007?
Your answer should be very brief. 0.89. What is the ratio of the Tax (as % of total tax revenue) of Congo (Republic) in 2006 to that in 2008?
Your answer should be very brief. 0.85. What is the ratio of the Tax (as % of total tax revenue) of El Salvador in 2006 to that in 2008?
Keep it short and to the point. 0.95. What is the ratio of the Tax (as % of total tax revenue) of Nepal in 2006 to that in 2008?
Keep it short and to the point. 0.82. What is the ratio of the Tax (as % of total tax revenue) in Slovak Republic in 2006 to that in 2008?
Offer a very short reply. 0.85. What is the ratio of the Tax (as % of total tax revenue) of Congo (Republic) in 2007 to that in 2008?
Your answer should be very brief. 0.9. What is the ratio of the Tax (as % of total tax revenue) of El Salvador in 2007 to that in 2008?
Provide a short and direct response. 0.99. What is the ratio of the Tax (as % of total tax revenue) of Slovak Republic in 2007 to that in 2008?
Offer a very short reply. 0.95. What is the difference between the highest and the second highest Tax (as % of total tax revenue) of Congo (Republic)?
Keep it short and to the point. 3.75. What is the difference between the highest and the second highest Tax (as % of total tax revenue) of El Salvador?
Your response must be concise. 0.33. What is the difference between the highest and the second highest Tax (as % of total tax revenue) in Nepal?
Your answer should be compact. 0.23. What is the difference between the highest and the second highest Tax (as % of total tax revenue) in Slovak Republic?
Give a very brief answer. 6.98. What is the difference between the highest and the lowest Tax (as % of total tax revenue) of Congo (Republic)?
Offer a terse response. 21.6. What is the difference between the highest and the lowest Tax (as % of total tax revenue) in El Salvador?
Make the answer very short. 4.55. What is the difference between the highest and the lowest Tax (as % of total tax revenue) in Nepal?
Provide a short and direct response. 3.57. What is the difference between the highest and the lowest Tax (as % of total tax revenue) in Slovak Republic?
Your answer should be compact. 13.3. 